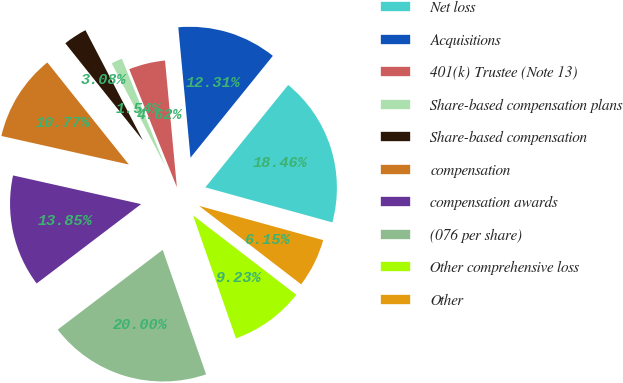<chart> <loc_0><loc_0><loc_500><loc_500><pie_chart><fcel>Net loss<fcel>Acquisitions<fcel>401(k) Trustee (Note 13)<fcel>Share-based compensation plans<fcel>Share-based compensation<fcel>compensation<fcel>compensation awards<fcel>(076 per share)<fcel>Other comprehensive loss<fcel>Other<nl><fcel>18.46%<fcel>12.31%<fcel>4.62%<fcel>1.54%<fcel>3.08%<fcel>10.77%<fcel>13.85%<fcel>20.0%<fcel>9.23%<fcel>6.15%<nl></chart> 